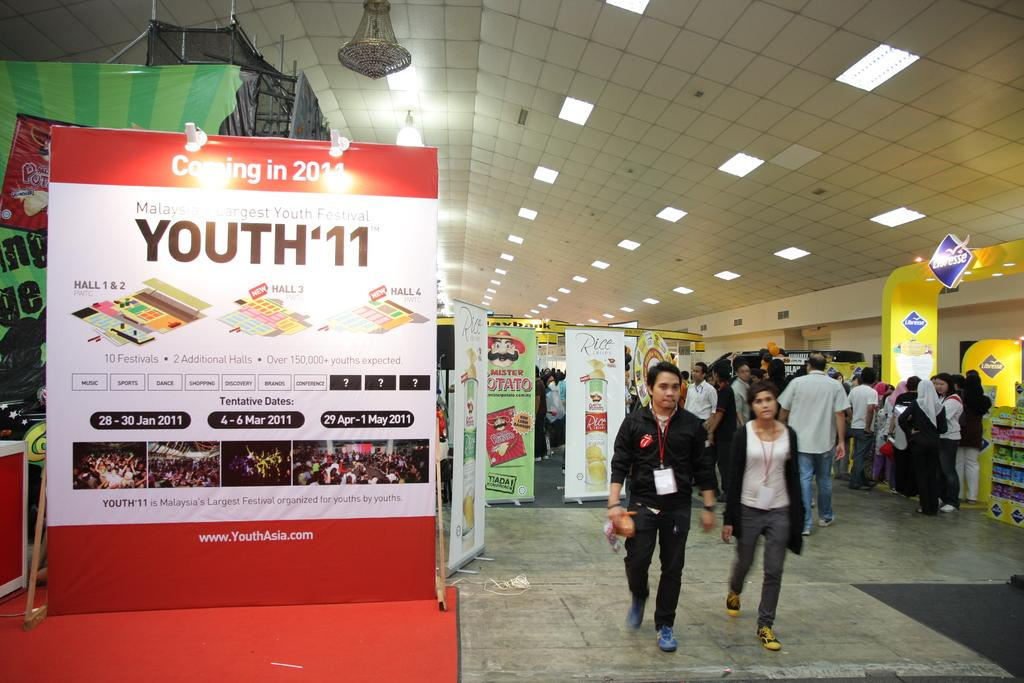<image>
Relay a brief, clear account of the picture shown. Youth '11 claims it is Malaysia's largest youth festival. 